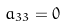<formula> <loc_0><loc_0><loc_500><loc_500>a _ { 3 3 } = 0</formula> 